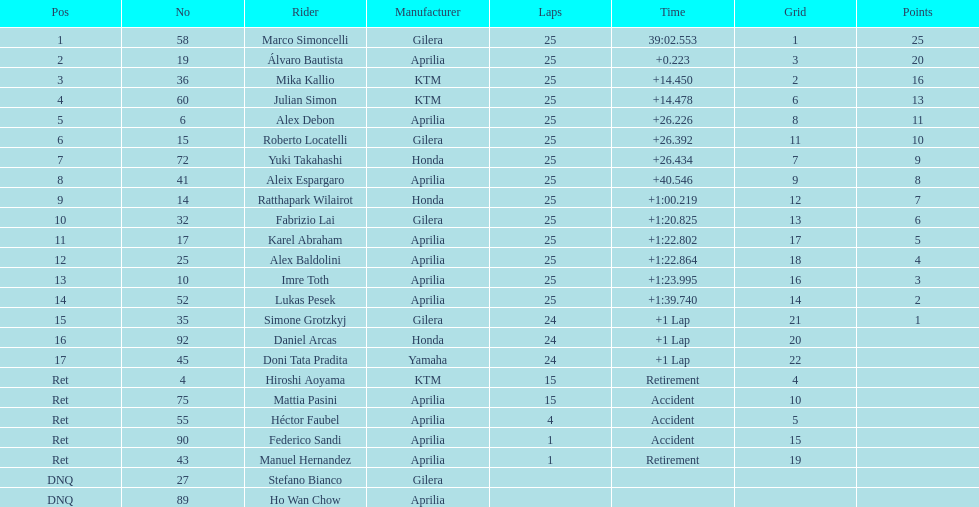The total amount of riders who did not qualify 2. Could you help me parse every detail presented in this table? {'header': ['Pos', 'No', 'Rider', 'Manufacturer', 'Laps', 'Time', 'Grid', 'Points'], 'rows': [['1', '58', 'Marco Simoncelli', 'Gilera', '25', '39:02.553', '1', '25'], ['2', '19', 'Álvaro Bautista', 'Aprilia', '25', '+0.223', '3', '20'], ['3', '36', 'Mika Kallio', 'KTM', '25', '+14.450', '2', '16'], ['4', '60', 'Julian Simon', 'KTM', '25', '+14.478', '6', '13'], ['5', '6', 'Alex Debon', 'Aprilia', '25', '+26.226', '8', '11'], ['6', '15', 'Roberto Locatelli', 'Gilera', '25', '+26.392', '11', '10'], ['7', '72', 'Yuki Takahashi', 'Honda', '25', '+26.434', '7', '9'], ['8', '41', 'Aleix Espargaro', 'Aprilia', '25', '+40.546', '9', '8'], ['9', '14', 'Ratthapark Wilairot', 'Honda', '25', '+1:00.219', '12', '7'], ['10', '32', 'Fabrizio Lai', 'Gilera', '25', '+1:20.825', '13', '6'], ['11', '17', 'Karel Abraham', 'Aprilia', '25', '+1:22.802', '17', '5'], ['12', '25', 'Alex Baldolini', 'Aprilia', '25', '+1:22.864', '18', '4'], ['13', '10', 'Imre Toth', 'Aprilia', '25', '+1:23.995', '16', '3'], ['14', '52', 'Lukas Pesek', 'Aprilia', '25', '+1:39.740', '14', '2'], ['15', '35', 'Simone Grotzkyj', 'Gilera', '24', '+1 Lap', '21', '1'], ['16', '92', 'Daniel Arcas', 'Honda', '24', '+1 Lap', '20', ''], ['17', '45', 'Doni Tata Pradita', 'Yamaha', '24', '+1 Lap', '22', ''], ['Ret', '4', 'Hiroshi Aoyama', 'KTM', '15', 'Retirement', '4', ''], ['Ret', '75', 'Mattia Pasini', 'Aprilia', '15', 'Accident', '10', ''], ['Ret', '55', 'Héctor Faubel', 'Aprilia', '4', 'Accident', '5', ''], ['Ret', '90', 'Federico Sandi', 'Aprilia', '1', 'Accident', '15', ''], ['Ret', '43', 'Manuel Hernandez', 'Aprilia', '1', 'Retirement', '19', ''], ['DNQ', '27', 'Stefano Bianco', 'Gilera', '', '', '', ''], ['DNQ', '89', 'Ho Wan Chow', 'Aprilia', '', '', '', '']]} 